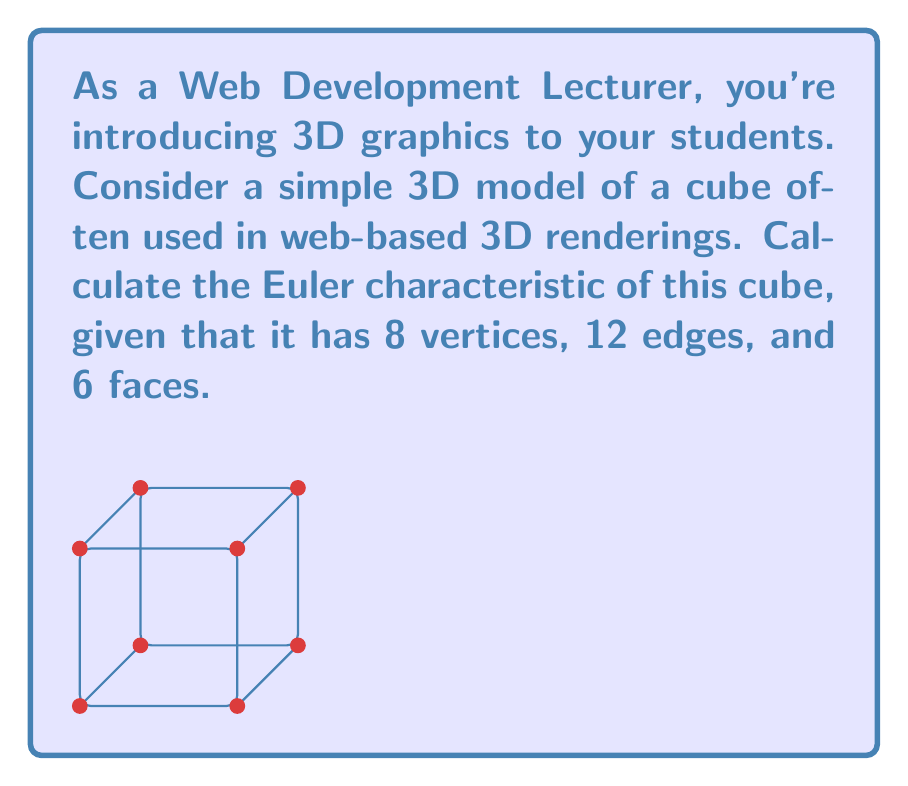Give your solution to this math problem. To calculate the Euler characteristic of a 3D object, we use the formula:

$$\chi = V - E + F$$

Where:
$\chi$ (chi) is the Euler characteristic
$V$ is the number of vertices
$E$ is the number of edges
$F$ is the number of faces

For the given cube:
$V = 8$ (vertices)
$E = 12$ (edges)
$F = 6$ (faces)

Let's substitute these values into the formula:

$$\chi = 8 - 12 + 6$$

Simplifying:
$$\chi = 2$$

The Euler characteristic of a cube (and any convex polyhedron homeomorphic to a sphere) is always 2. This is a fundamental result in topology, and it's invariant under continuous deformations of the shape.
Answer: $\chi = 2$ 